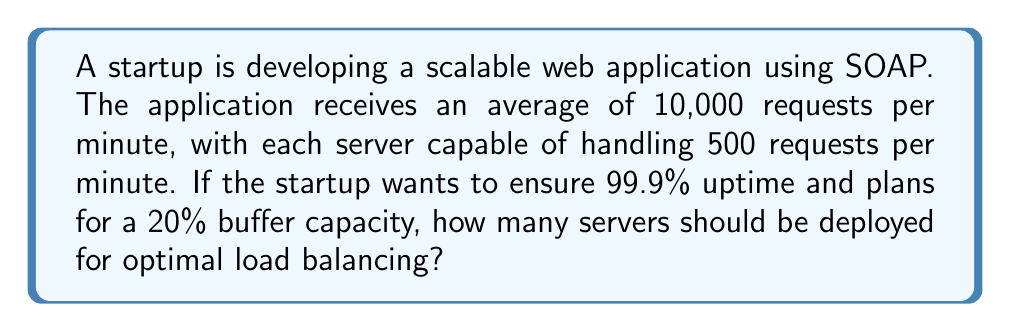Could you help me with this problem? Let's approach this step-by-step:

1. Calculate the base number of servers needed:
   $$\text{Base servers} = \frac{\text{Total requests per minute}}{\text{Requests per server per minute}}$$
   $$\text{Base servers} = \frac{10,000}{500} = 20$$

2. Account for 99.9% uptime:
   This means we need to plan for 0.1% downtime. In a distributed system, we can achieve this by adding one additional server.
   $$\text{Servers with uptime consideration} = 20 + 1 = 21$$

3. Add 20% buffer capacity:
   $$\text{Buffer} = 21 \times 0.20 = 4.2$$
   Round up to the nearest whole number: 5

4. Calculate the final number of servers:
   $$\text{Total servers} = 21 + 5 = 26$$

Therefore, the optimal number of servers for load balancing in this distributed system is 26.
Answer: 26 servers 